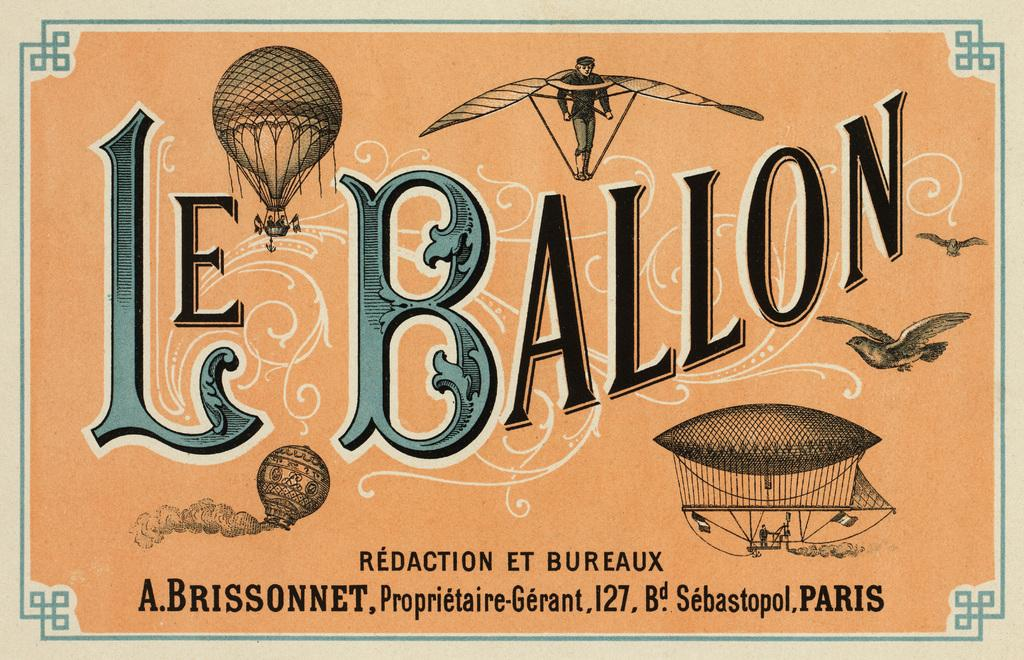Provide a one-sentence caption for the provided image. A french advertisment for hot air balloons displayed the words "Le Ballon" on the front. 